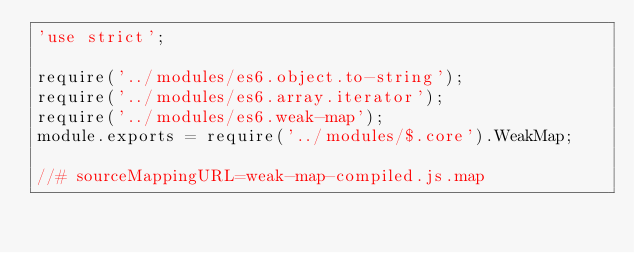Convert code to text. <code><loc_0><loc_0><loc_500><loc_500><_JavaScript_>'use strict';

require('../modules/es6.object.to-string');
require('../modules/es6.array.iterator');
require('../modules/es6.weak-map');
module.exports = require('../modules/$.core').WeakMap;

//# sourceMappingURL=weak-map-compiled.js.map</code> 